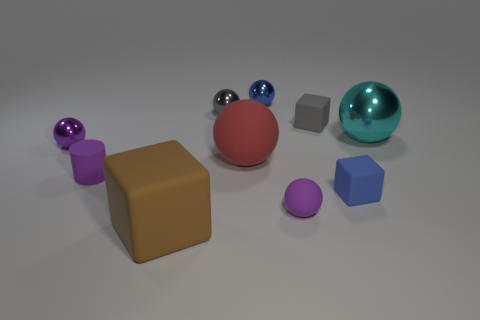Subtract 3 spheres. How many spheres are left? 3 Subtract all red spheres. How many spheres are left? 5 Subtract all purple metallic spheres. How many spheres are left? 5 Subtract all yellow balls. Subtract all green cylinders. How many balls are left? 6 Subtract all balls. How many objects are left? 4 Add 1 brown matte objects. How many brown matte objects exist? 2 Subtract 0 blue cylinders. How many objects are left? 10 Subtract all large cyan rubber spheres. Subtract all gray matte objects. How many objects are left? 9 Add 7 big brown objects. How many big brown objects are left? 8 